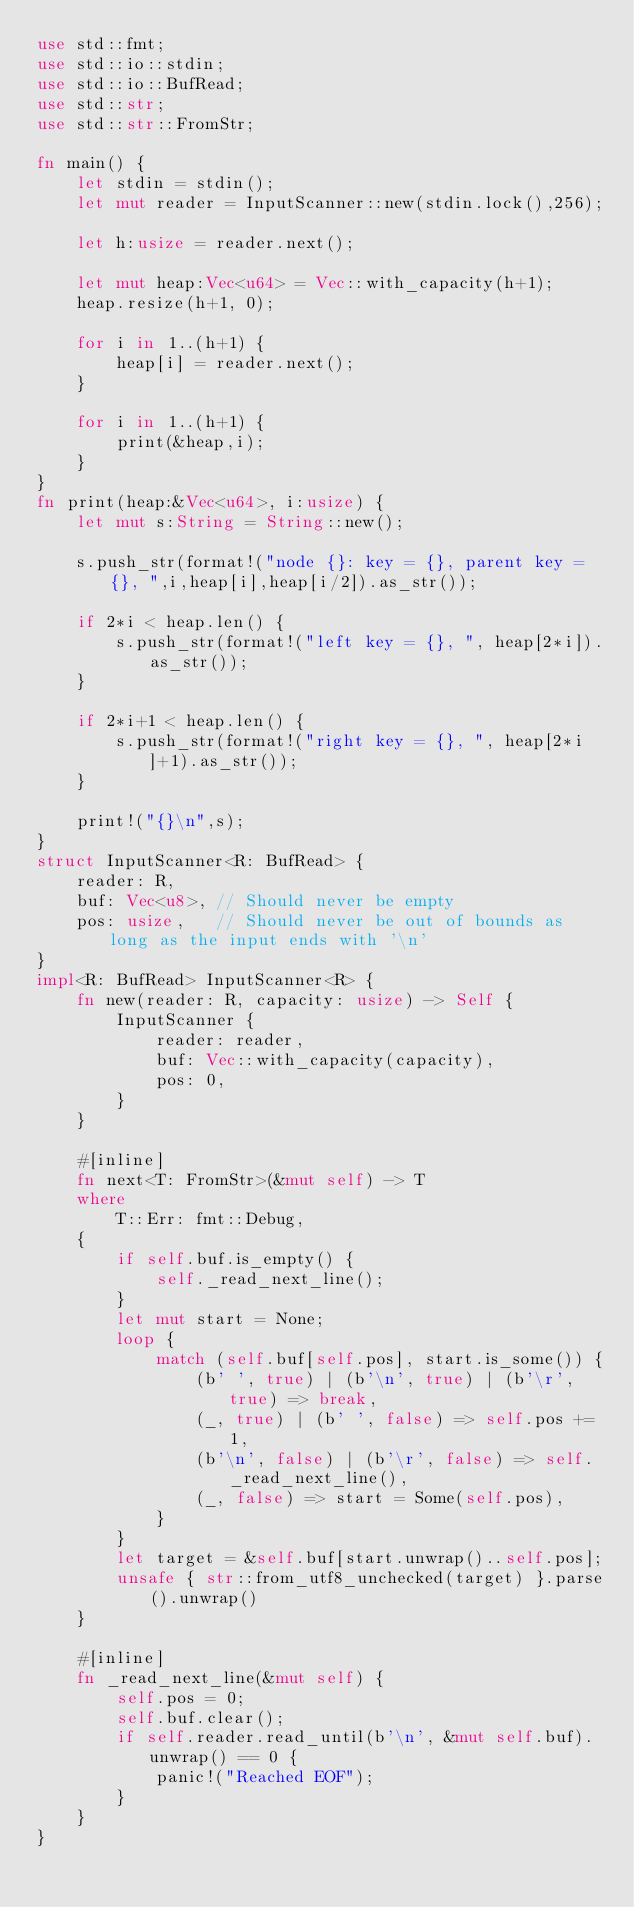<code> <loc_0><loc_0><loc_500><loc_500><_Rust_>use std::fmt;
use std::io::stdin;
use std::io::BufRead;
use std::str;
use std::str::FromStr;

fn main() {
	let stdin = stdin();
	let mut reader = InputScanner::new(stdin.lock(),256);

	let h:usize = reader.next();

	let mut heap:Vec<u64> = Vec::with_capacity(h+1);
	heap.resize(h+1, 0);

	for i in 1..(h+1) {
		heap[i] = reader.next();
	}

	for i in 1..(h+1) {
		print(&heap,i);
	}
}
fn print(heap:&Vec<u64>, i:usize) {
	let mut s:String = String::new();

	s.push_str(format!("node {}: key = {}, parent key = {}, ",i,heap[i],heap[i/2]).as_str());

	if 2*i < heap.len() {
		s.push_str(format!("left key = {}, ", heap[2*i]).as_str());
	}

	if 2*i+1 < heap.len() {
		s.push_str(format!("right key = {}, ", heap[2*i]+1).as_str());
	}

	print!("{}\n",s);
}
struct InputScanner<R: BufRead> {
	reader: R,
	buf: Vec<u8>, // Should never be empty
	pos: usize,   // Should never be out of bounds as long as the input ends with '\n'
}
impl<R: BufRead> InputScanner<R> {
	fn new(reader: R, capacity: usize) -> Self {
		InputScanner {
			reader: reader,
			buf: Vec::with_capacity(capacity),
			pos: 0,
		}
	}

	#[inline]
	fn next<T: FromStr>(&mut self) -> T
	where
		T::Err: fmt::Debug,
	{
		if self.buf.is_empty() {
			self._read_next_line();
		}
		let mut start = None;
		loop {
			match (self.buf[self.pos], start.is_some()) {
				(b' ', true) | (b'\n', true) | (b'\r', true) => break,
				(_, true) | (b' ', false) => self.pos += 1,
				(b'\n', false) | (b'\r', false) => self._read_next_line(),
				(_, false) => start = Some(self.pos),
			}
		}
		let target = &self.buf[start.unwrap()..self.pos];
		unsafe { str::from_utf8_unchecked(target) }.parse().unwrap()
	}

	#[inline]
	fn _read_next_line(&mut self) {
		self.pos = 0;
		self.buf.clear();
		if self.reader.read_until(b'\n', &mut self.buf).unwrap() == 0 {
			panic!("Reached EOF");
		}
	}
}

</code> 